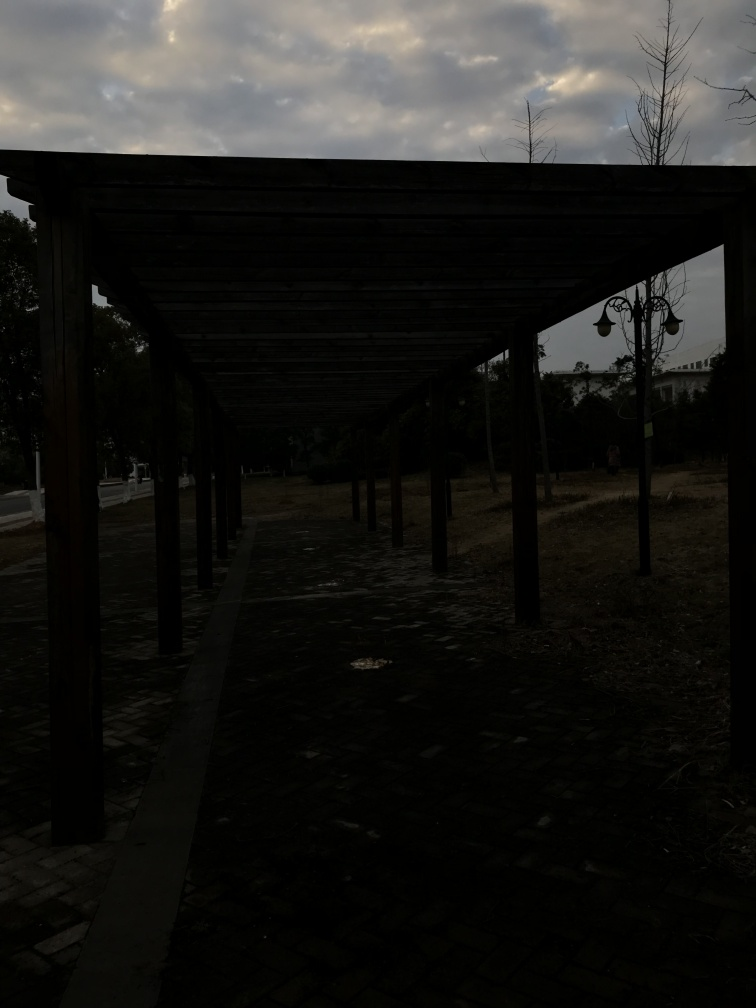What might be the function of this space? Based on the context, this space seems to serve as a tranquil area for walking, offering shelter from sun or light rain, and possibly a place for quiet reflection, perhaps within a park or a similar recreational setting. 